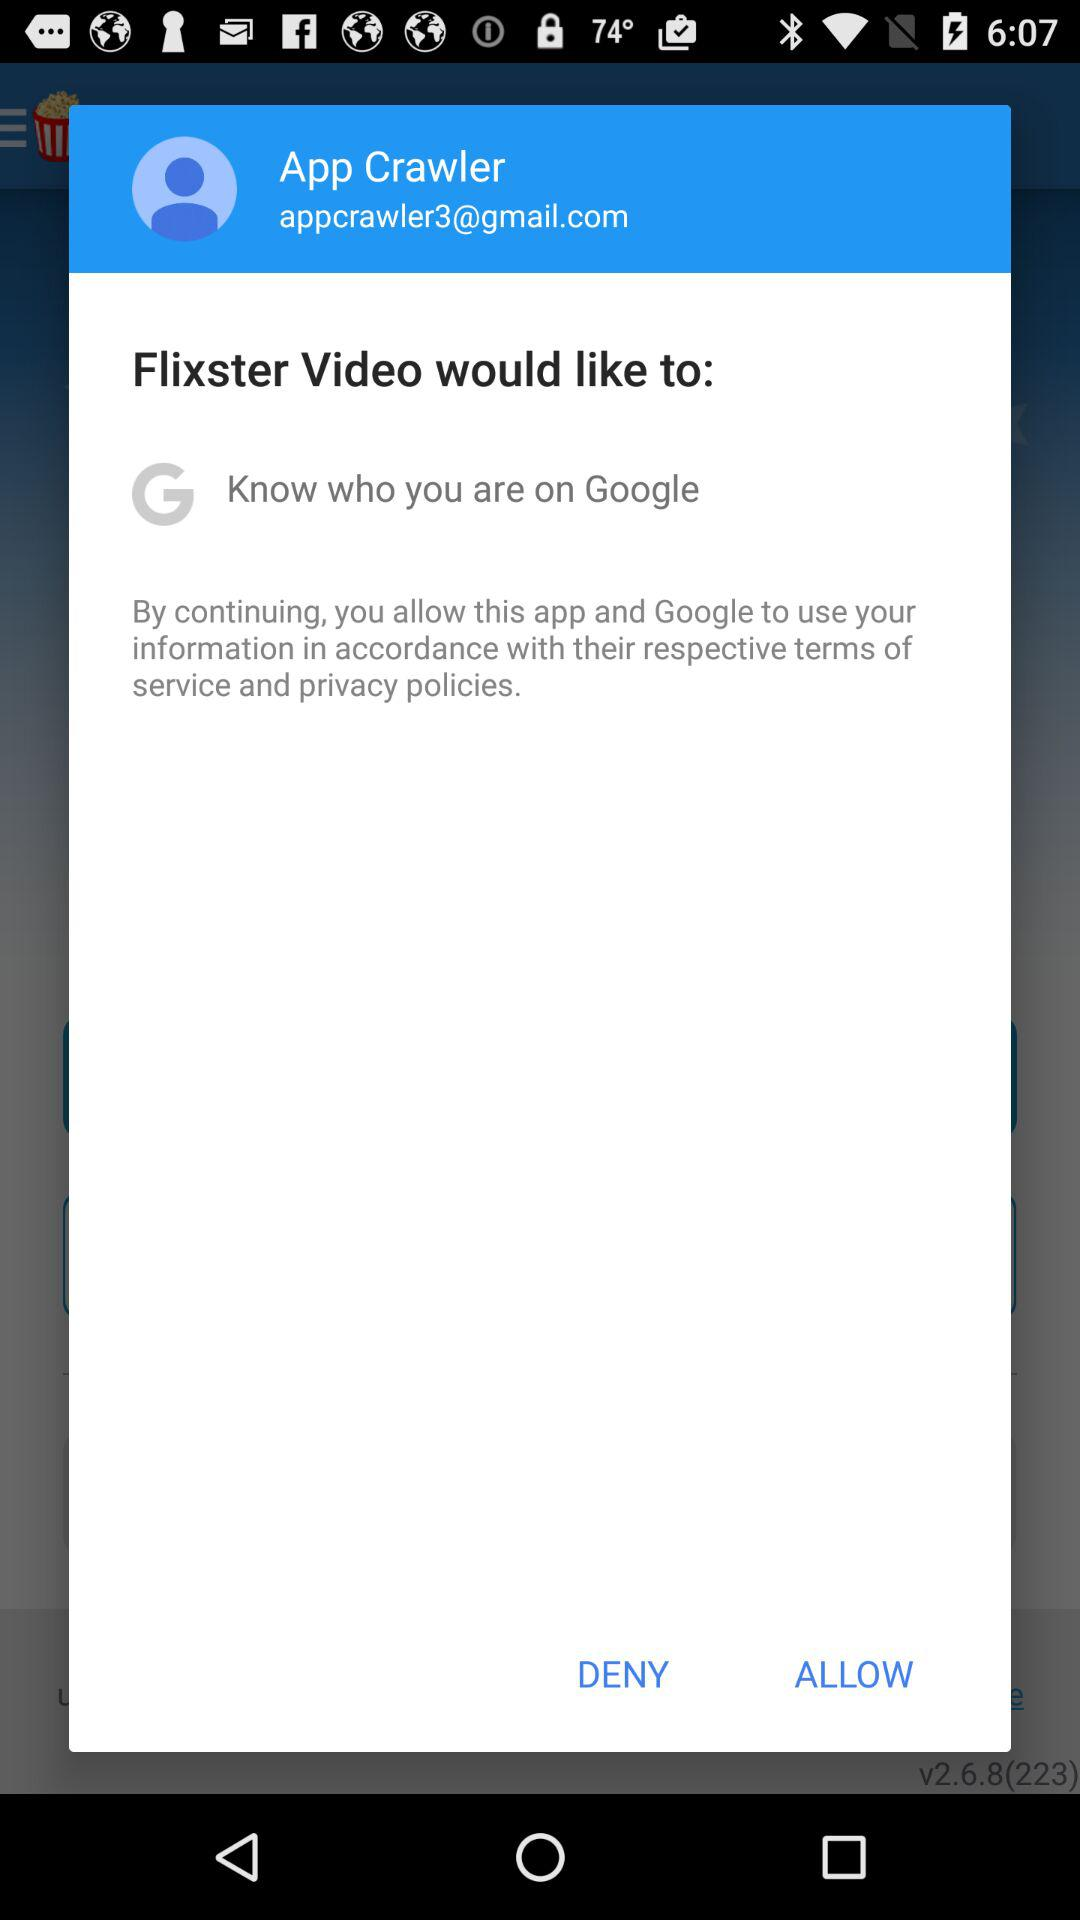Has the user agreed to the terms of service and privacy policy?
When the provided information is insufficient, respond with <no answer>. <no answer> 